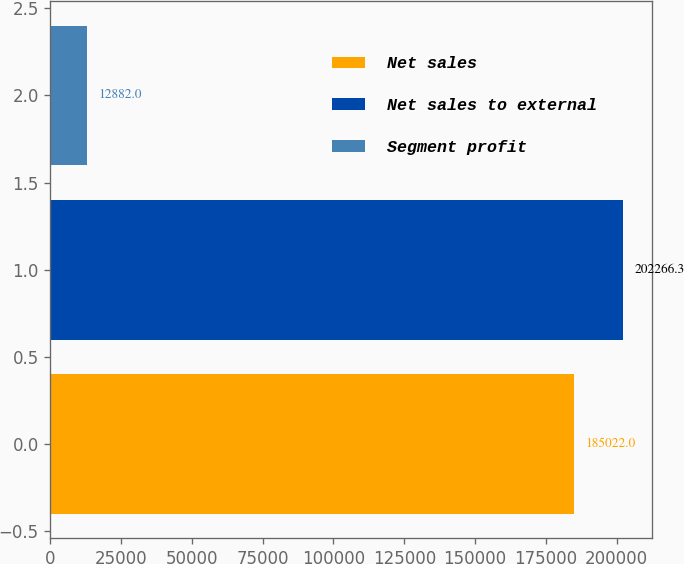Convert chart. <chart><loc_0><loc_0><loc_500><loc_500><bar_chart><fcel>Net sales<fcel>Net sales to external<fcel>Segment profit<nl><fcel>185022<fcel>202266<fcel>12882<nl></chart> 